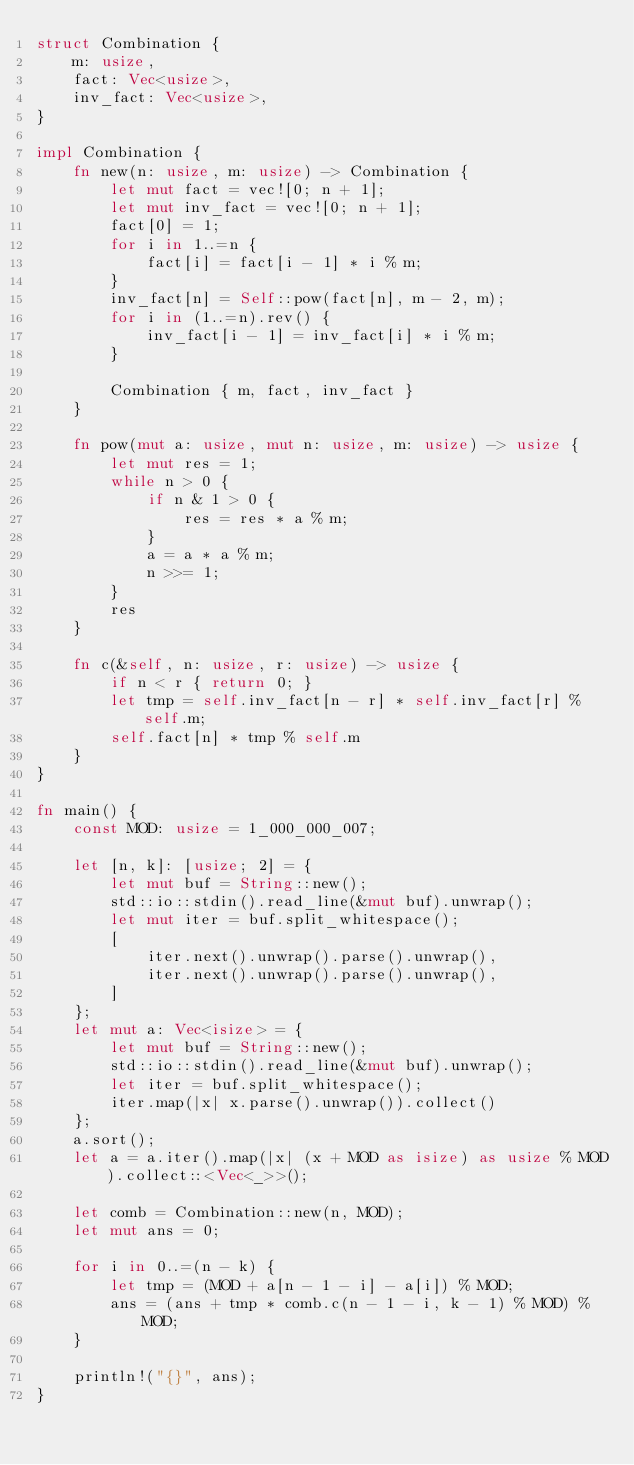<code> <loc_0><loc_0><loc_500><loc_500><_Rust_>struct Combination {
    m: usize,
    fact: Vec<usize>,
    inv_fact: Vec<usize>,
}

impl Combination {
    fn new(n: usize, m: usize) -> Combination {
        let mut fact = vec![0; n + 1];
        let mut inv_fact = vec![0; n + 1];
        fact[0] = 1;
        for i in 1..=n {
            fact[i] = fact[i - 1] * i % m;
        }
        inv_fact[n] = Self::pow(fact[n], m - 2, m);
        for i in (1..=n).rev() {
            inv_fact[i - 1] = inv_fact[i] * i % m;
        }

        Combination { m, fact, inv_fact }
    }

    fn pow(mut a: usize, mut n: usize, m: usize) -> usize {
        let mut res = 1;
        while n > 0 {
            if n & 1 > 0 {
                res = res * a % m;
            }
            a = a * a % m;
            n >>= 1;
        }
        res
    }
    
    fn c(&self, n: usize, r: usize) -> usize {
        if n < r { return 0; }
        let tmp = self.inv_fact[n - r] * self.inv_fact[r] % self.m;
        self.fact[n] * tmp % self.m
    }
}

fn main() {
    const MOD: usize = 1_000_000_007;

    let [n, k]: [usize; 2] = {
        let mut buf = String::new();
        std::io::stdin().read_line(&mut buf).unwrap();
        let mut iter = buf.split_whitespace();
        [
            iter.next().unwrap().parse().unwrap(),
            iter.next().unwrap().parse().unwrap(),
        ]
    };
    let mut a: Vec<isize> = {
        let mut buf = String::new();
        std::io::stdin().read_line(&mut buf).unwrap();
        let iter = buf.split_whitespace();
        iter.map(|x| x.parse().unwrap()).collect()
    };
    a.sort();
    let a = a.iter().map(|x| (x + MOD as isize) as usize % MOD).collect::<Vec<_>>();

    let comb = Combination::new(n, MOD);
    let mut ans = 0;

    for i in 0..=(n - k) {
        let tmp = (MOD + a[n - 1 - i] - a[i]) % MOD;
        ans = (ans + tmp * comb.c(n - 1 - i, k - 1) % MOD) % MOD;
    }

    println!("{}", ans);
}</code> 